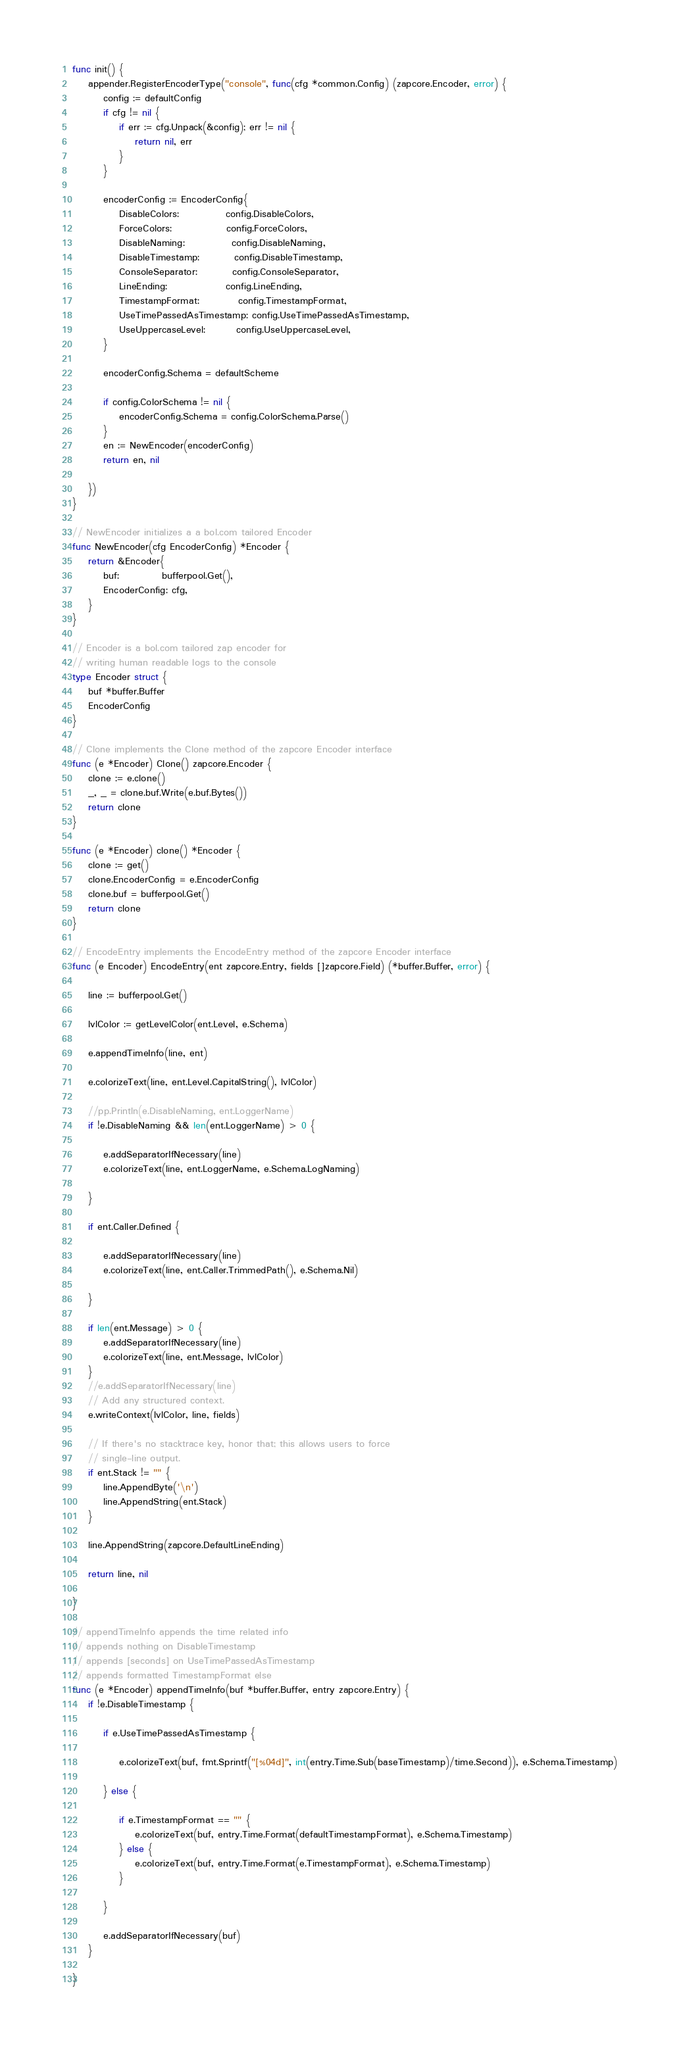<code> <loc_0><loc_0><loc_500><loc_500><_Go_>func init() {
	appender.RegisterEncoderType("console", func(cfg *common.Config) (zapcore.Encoder, error) {
		config := defaultConfig
		if cfg != nil {
			if err := cfg.Unpack(&config); err != nil {
				return nil, err
			}
		}

		encoderConfig := EncoderConfig{
			DisableColors:            config.DisableColors,
			ForceColors:              config.ForceColors,
			DisableNaming:            config.DisableNaming,
			DisableTimestamp:         config.DisableTimestamp,
			ConsoleSeparator:         config.ConsoleSeparator,
			LineEnding:               config.LineEnding,
			TimestampFormat:          config.TimestampFormat,
			UseTimePassedAsTimestamp: config.UseTimePassedAsTimestamp,
			UseUppercaseLevel:        config.UseUppercaseLevel,
		}

		encoderConfig.Schema = defaultScheme

		if config.ColorSchema != nil {
			encoderConfig.Schema = config.ColorSchema.Parse()
		}
		en := NewEncoder(encoderConfig)
		return en, nil

	})
}

// NewEncoder initializes a a bol.com tailored Encoder
func NewEncoder(cfg EncoderConfig) *Encoder {
	return &Encoder{
		buf:           bufferpool.Get(),
		EncoderConfig: cfg,
	}
}

// Encoder is a bol.com tailored zap encoder for
// writing human readable logs to the console
type Encoder struct {
	buf *buffer.Buffer
	EncoderConfig
}

// Clone implements the Clone method of the zapcore Encoder interface
func (e *Encoder) Clone() zapcore.Encoder {
	clone := e.clone()
	_, _ = clone.buf.Write(e.buf.Bytes())
	return clone
}

func (e *Encoder) clone() *Encoder {
	clone := get()
	clone.EncoderConfig = e.EncoderConfig
	clone.buf = bufferpool.Get()
	return clone
}

// EncodeEntry implements the EncodeEntry method of the zapcore Encoder interface
func (e Encoder) EncodeEntry(ent zapcore.Entry, fields []zapcore.Field) (*buffer.Buffer, error) {

	line := bufferpool.Get()

	lvlColor := getLevelColor(ent.Level, e.Schema)

	e.appendTimeInfo(line, ent)

	e.colorizeText(line, ent.Level.CapitalString(), lvlColor)

	//pp.Println(e.DisableNaming, ent.LoggerName)
	if !e.DisableNaming && len(ent.LoggerName) > 0 {

		e.addSeparatorIfNecessary(line)
		e.colorizeText(line, ent.LoggerName, e.Schema.LogNaming)

	}

	if ent.Caller.Defined {

		e.addSeparatorIfNecessary(line)
		e.colorizeText(line, ent.Caller.TrimmedPath(), e.Schema.Nil)

	}

	if len(ent.Message) > 0 {
		e.addSeparatorIfNecessary(line)
		e.colorizeText(line, ent.Message, lvlColor)
	}
	//e.addSeparatorIfNecessary(line)
	// Add any structured context.
	e.writeContext(lvlColor, line, fields)

	// If there's no stacktrace key, honor that; this allows users to force
	// single-line output.
	if ent.Stack != "" {
		line.AppendByte('\n')
		line.AppendString(ent.Stack)
	}

	line.AppendString(zapcore.DefaultLineEnding)

	return line, nil

}

// appendTimeInfo appends the time related info
// appends nothing on DisableTimestamp
// appends [seconds] on UseTimePassedAsTimestamp
// appends formatted TimestampFormat else
func (e *Encoder) appendTimeInfo(buf *buffer.Buffer, entry zapcore.Entry) {
	if !e.DisableTimestamp {

		if e.UseTimePassedAsTimestamp {

			e.colorizeText(buf, fmt.Sprintf("[%04d]", int(entry.Time.Sub(baseTimestamp)/time.Second)), e.Schema.Timestamp)

		} else {

			if e.TimestampFormat == "" {
				e.colorizeText(buf, entry.Time.Format(defaultTimestampFormat), e.Schema.Timestamp)
			} else {
				e.colorizeText(buf, entry.Time.Format(e.TimestampFormat), e.Schema.Timestamp)
			}

		}

		e.addSeparatorIfNecessary(buf)
	}

}
</code> 